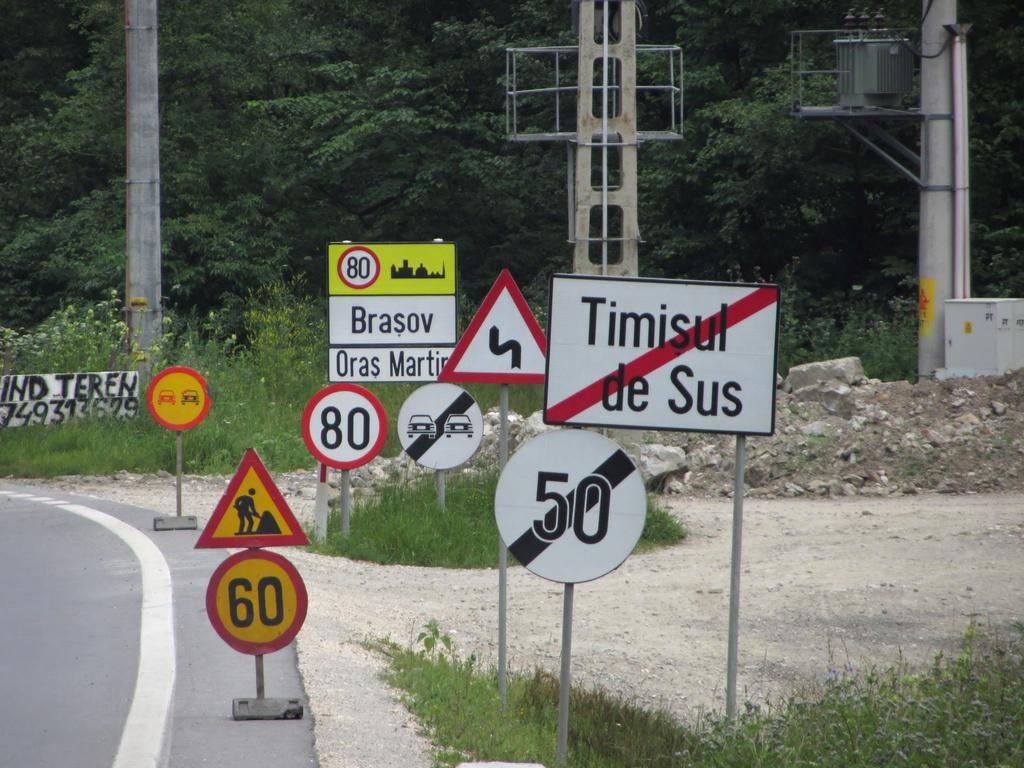<image>
Summarize the visual content of the image. A sign for Timisul de Sus has a red diagonal line through it. 